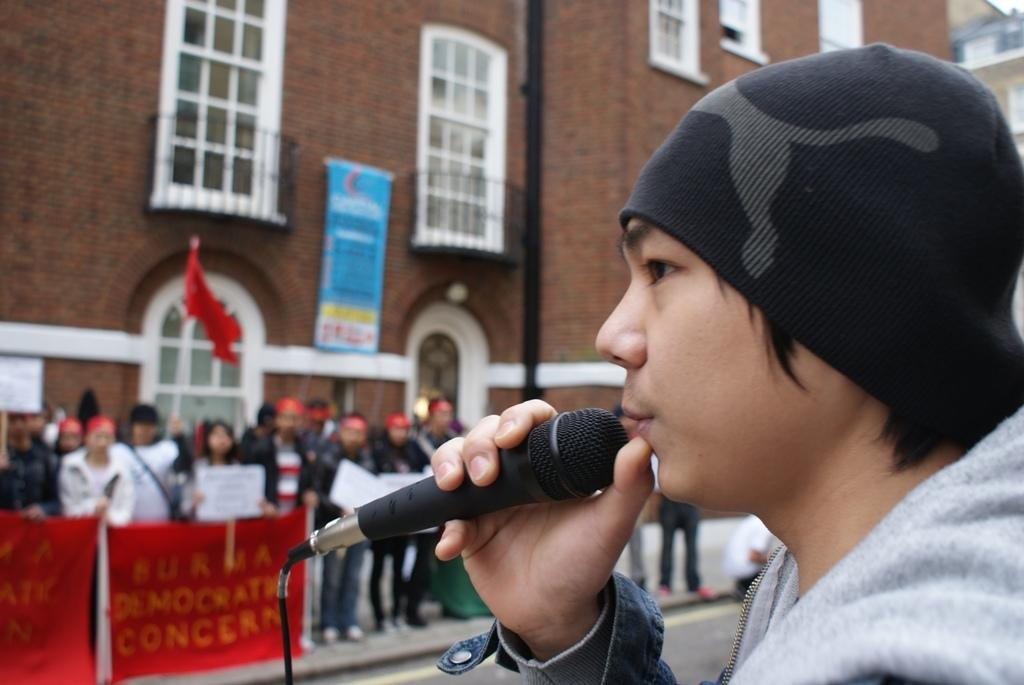What is the main subject of the image? There is a person in the image. Can you describe the person's attire? The person is wearing a cap. What is the person holding in the image? The person is holding a microphone. What can be seen in the background of the image? There is a group of persons and a building in the background of the image. How many times does the person kick the ball in the image? There is no ball present in the image, so the person cannot kick it. 